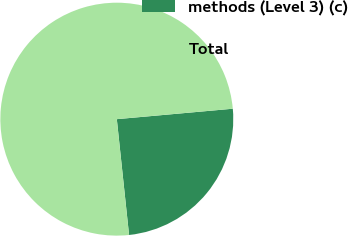Convert chart. <chart><loc_0><loc_0><loc_500><loc_500><pie_chart><fcel>methods (Level 3) (c)<fcel>Total<nl><fcel>24.75%<fcel>75.25%<nl></chart> 